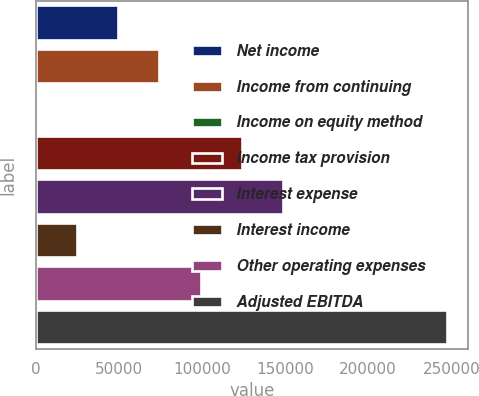Convert chart. <chart><loc_0><loc_0><loc_500><loc_500><bar_chart><fcel>Net income<fcel>Income from continuing<fcel>Income on equity method<fcel>Income tax provision<fcel>Interest expense<fcel>Interest income<fcel>Other operating expenses<fcel>Adjusted EBITDA<nl><fcel>49543.2<fcel>74307.3<fcel>15<fcel>123836<fcel>148600<fcel>24779.1<fcel>99071.4<fcel>247656<nl></chart> 